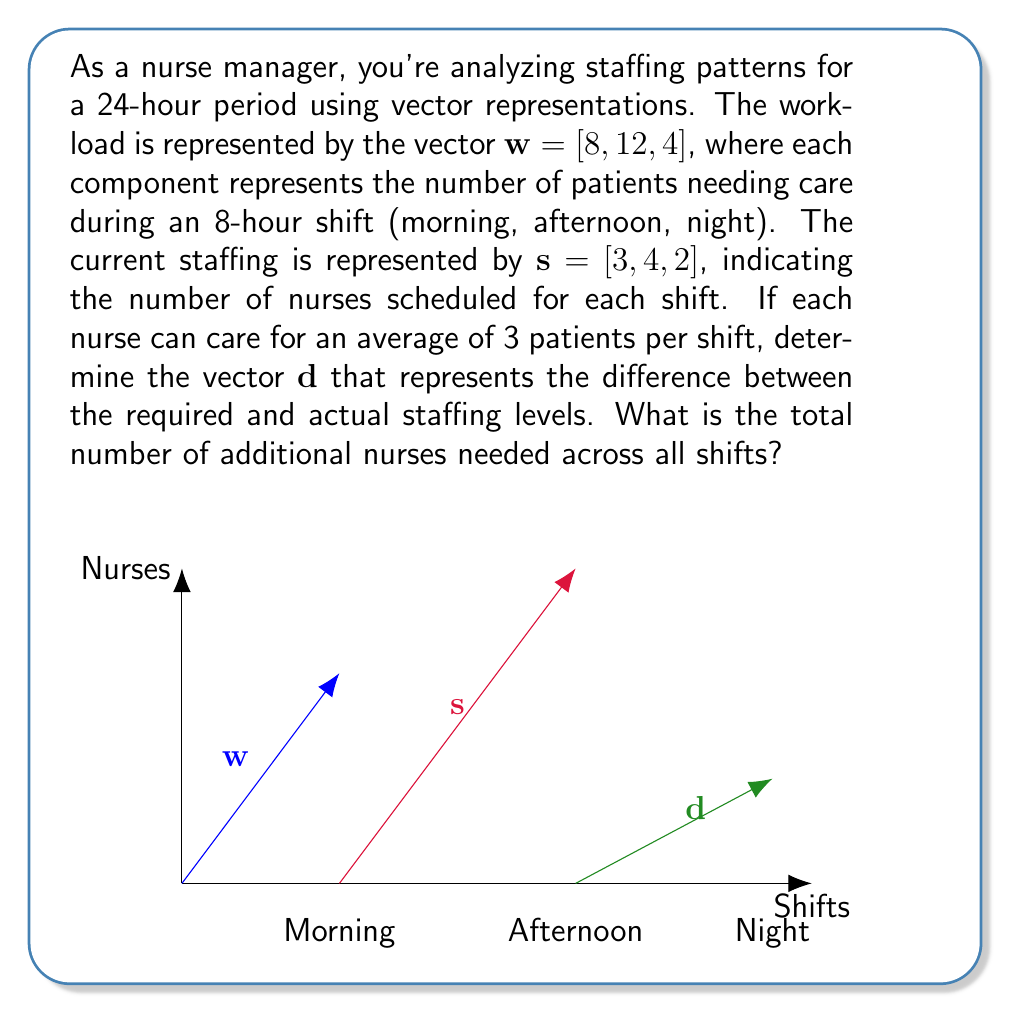Solve this math problem. Let's approach this step-by-step:

1) First, we need to calculate the required number of nurses for each shift based on the workload vector $\mathbf{w}$:
   Required nurses = $\mathbf{w} / 3$ (since each nurse can care for 3 patients)
   $\mathbf{r} = [8/3, 12/3, 4/3] = [2.67, 4, 1.33]$

2) Now, we can calculate the difference vector $\mathbf{d}$ by subtracting the current staffing vector $\mathbf{s}$ from the required staffing vector $\mathbf{r}$:
   $\mathbf{d} = \mathbf{r} - \mathbf{s}$
   $\mathbf{d} = [2.67, 4, 1.33] - [3, 4, 2]$
   $\mathbf{d} = [-0.33, 0, -0.67]$

3) To determine the total number of additional nurses needed, we need to round up any positive values in $\mathbf{d}$ (as we can't have fractional nurses) and sum them:
   Morning shift: -0.33 (rounded up to 0)
   Afternoon shift: 0
   Night shift: -0.67 (rounded up to 0)

4) The sum of these rounded values is 0 + 0 + 0 = 0

Therefore, no additional nurses are needed across all shifts. In fact, there's a slight overstaffing in the morning and night shifts.
Answer: 0 additional nurses 